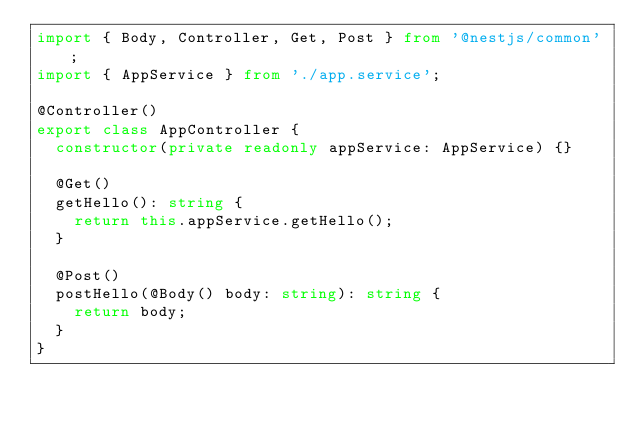<code> <loc_0><loc_0><loc_500><loc_500><_TypeScript_>import { Body, Controller, Get, Post } from '@nestjs/common';
import { AppService } from './app.service';

@Controller()
export class AppController {
  constructor(private readonly appService: AppService) {}

  @Get()
  getHello(): string {
    return this.appService.getHello();
  }

  @Post()
  postHello(@Body() body: string): string {
    return body;
  }
}
</code> 